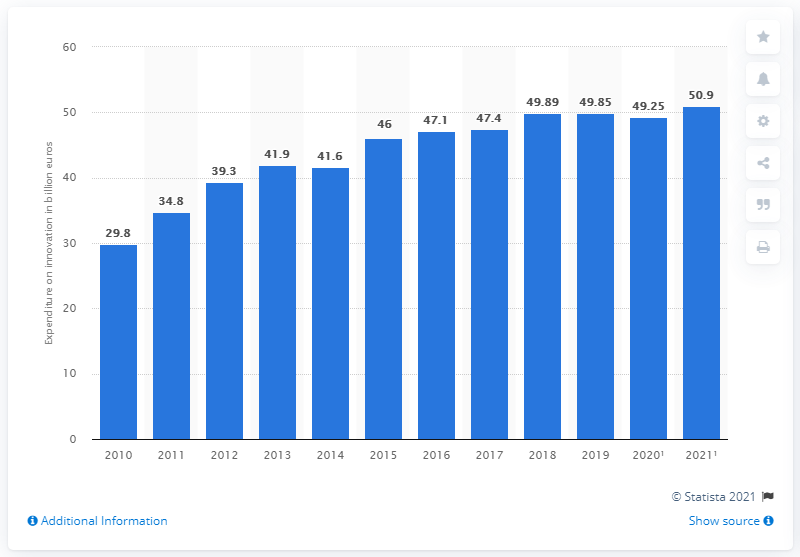Outline some significant characteristics in this image. The German car industry intended to allocate 50.9 billion euros towards innovation activities in 2021. 